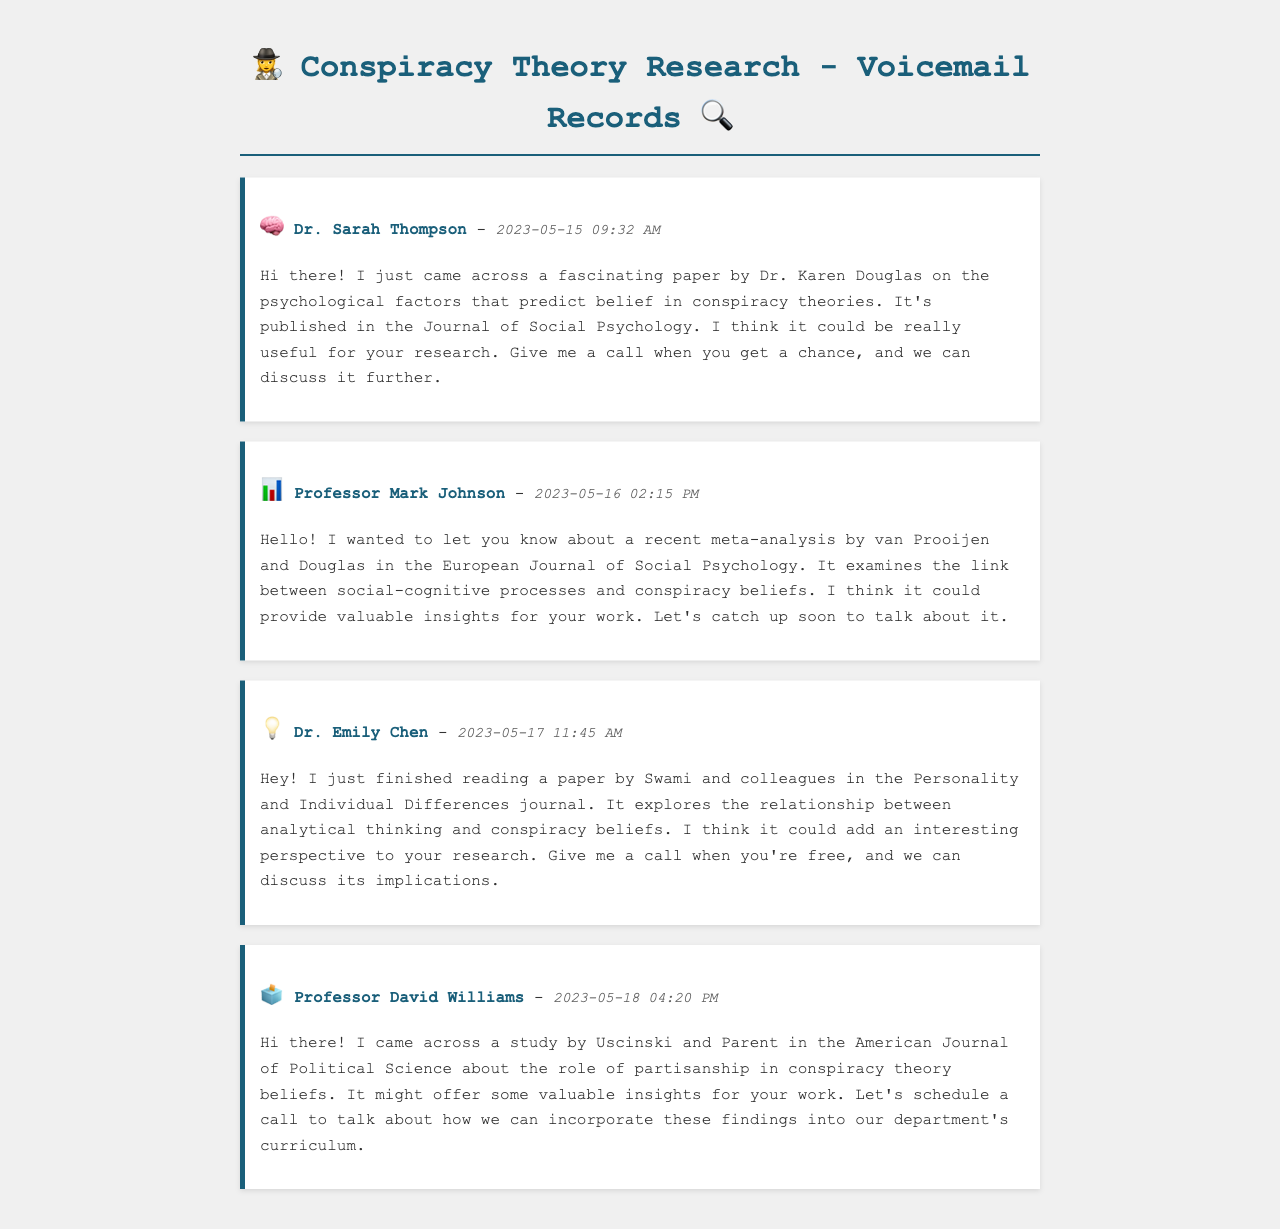What is the name of the first caller? The first voicemail is from Dr. Sarah Thompson.
Answer: Dr. Sarah Thompson What is the title of Dr. Karen Douglas’s paper? The paper mentioned is about psychological factors that predict belief in conspiracy theories.
Answer: Psychological factors that predict belief in conspiracy theories What date did Professor Mark Johnson leave his voicemail? The voicemail from Professor Mark Johnson was left on May 16, 2023.
Answer: May 16, 2023 Which journal published the paper by Swami and colleagues? The paper by Swami and colleagues was published in the Personality and Individual Differences journal.
Answer: Personality and Individual Differences What psychological aspect does the meta-analysis by van Prooijen and Douglas examine? The meta-analysis examines the link between social-cognitive processes and conspiracy beliefs.
Answer: Social-cognitive processes How many colleagues shared research papers in total? There are four different colleagues mentioned in the voicemails.
Answer: Four What was the time of Dr. Emily Chen's voicemail? Dr. Emily Chen's voicemail was left at 11:45 AM.
Answer: 11:45 AM What topic does Professor David Williams's study focus on? The study mentioned focuses on the role of partisanship in conspiracy theory beliefs.
Answer: Role of partisanship 